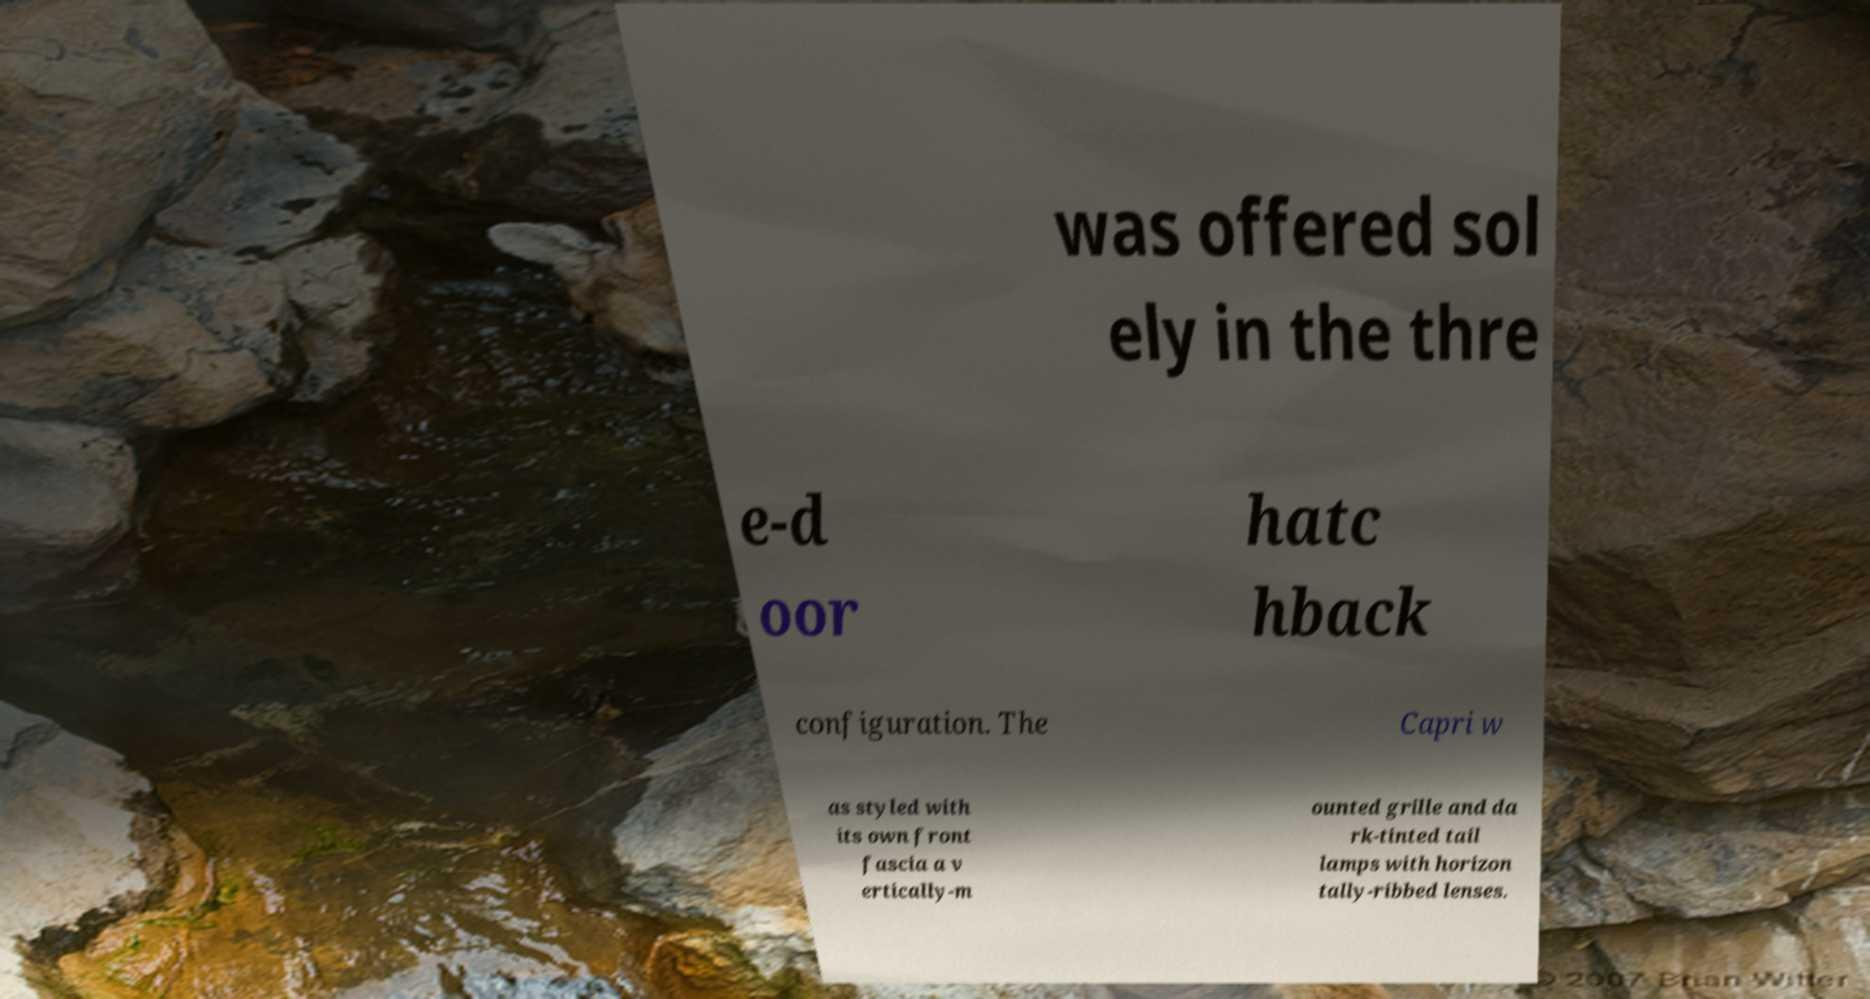Can you accurately transcribe the text from the provided image for me? was offered sol ely in the thre e-d oor hatc hback configuration. The Capri w as styled with its own front fascia a v ertically-m ounted grille and da rk-tinted tail lamps with horizon tally-ribbed lenses. 